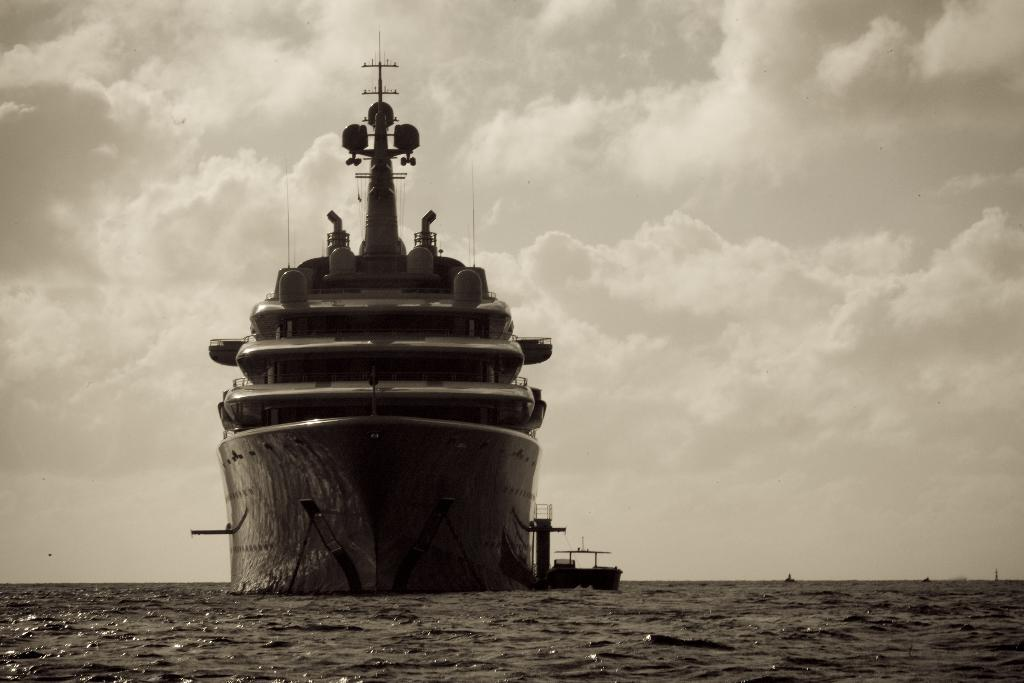What type of watercraft can be seen in the image? There is a ship and a boat in the image. Where are the ship and boat located? Both the ship and boat are on the water in the image. What can be seen in the background of the image? The sky is visible in the background of the image. How many rabbits are hopping on the ship in the image? There are no rabbits present in the image; it features a ship and a boat on the water. What type of shock can be seen affecting the boat in the image? There is no shock present in the image; the boat and ship are both stationary on the water. 